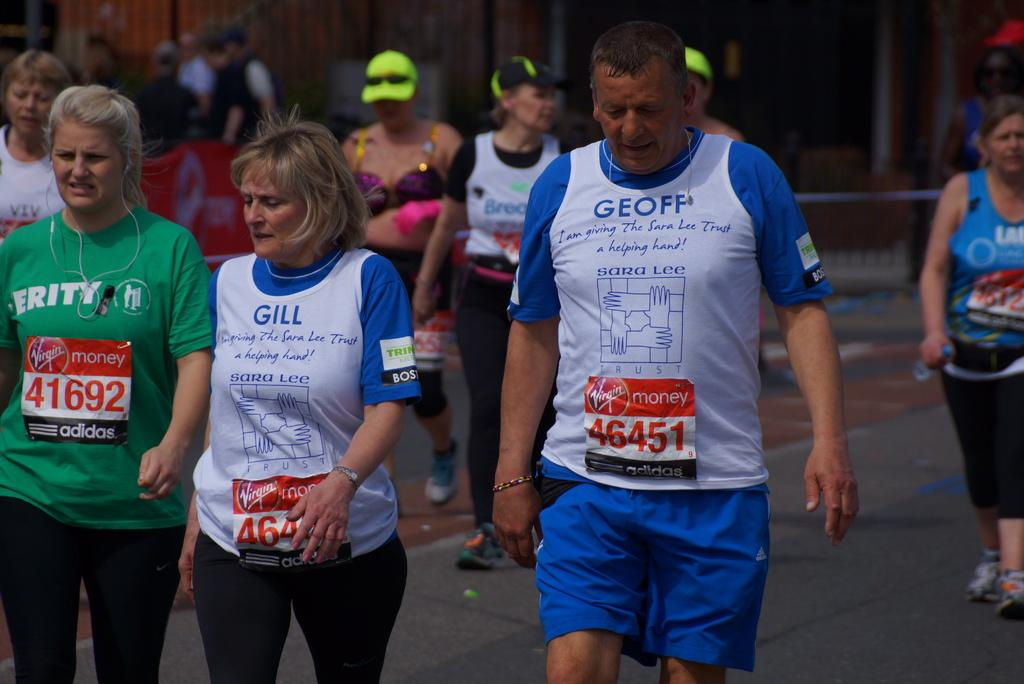<image>
Provide a brief description of the given image. Two women and a man with number 41692 and 46451 place on their shirts. 